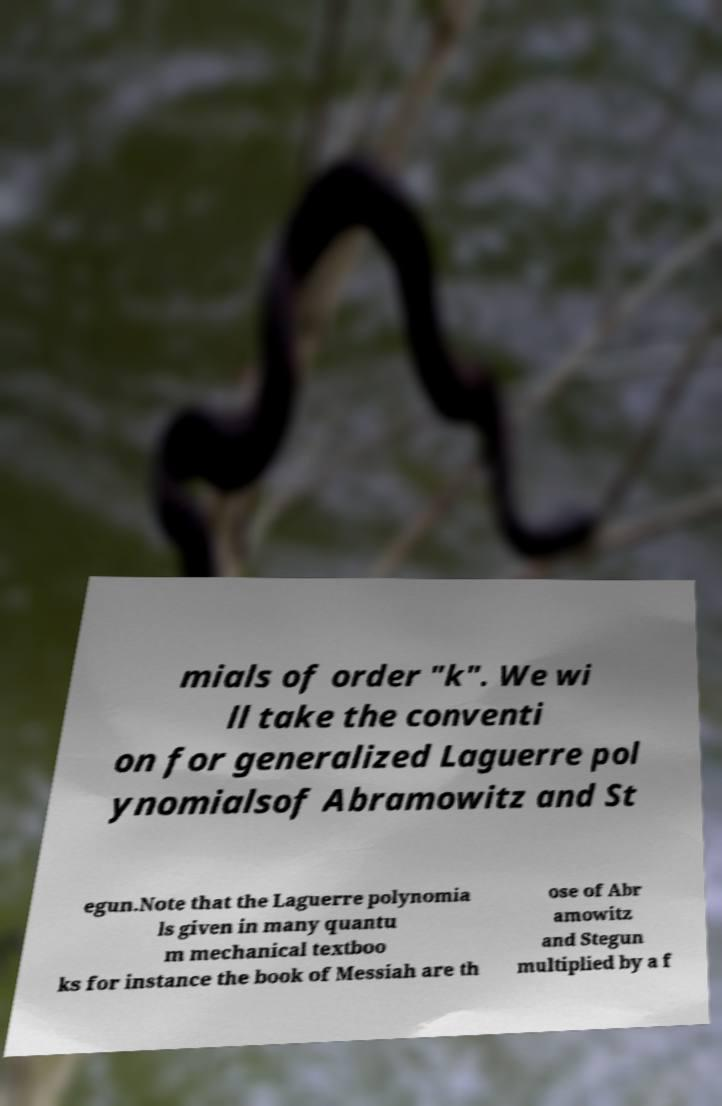Can you read and provide the text displayed in the image?This photo seems to have some interesting text. Can you extract and type it out for me? mials of order "k". We wi ll take the conventi on for generalized Laguerre pol ynomialsof Abramowitz and St egun.Note that the Laguerre polynomia ls given in many quantu m mechanical textboo ks for instance the book of Messiah are th ose of Abr amowitz and Stegun multiplied by a f 